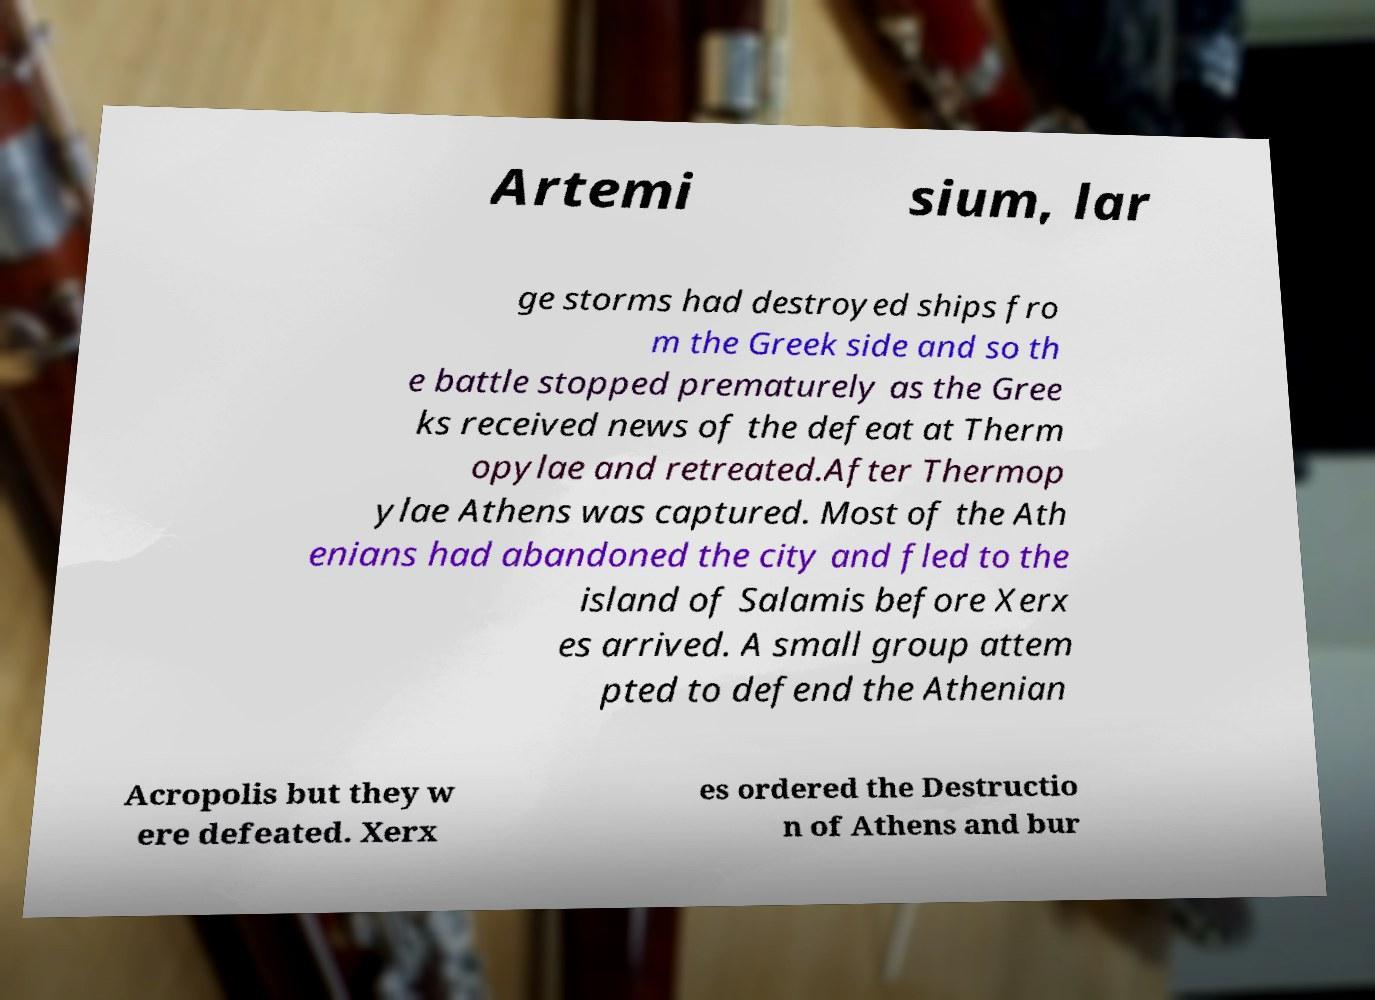For documentation purposes, I need the text within this image transcribed. Could you provide that? Artemi sium, lar ge storms had destroyed ships fro m the Greek side and so th e battle stopped prematurely as the Gree ks received news of the defeat at Therm opylae and retreated.After Thermop ylae Athens was captured. Most of the Ath enians had abandoned the city and fled to the island of Salamis before Xerx es arrived. A small group attem pted to defend the Athenian Acropolis but they w ere defeated. Xerx es ordered the Destructio n of Athens and bur 